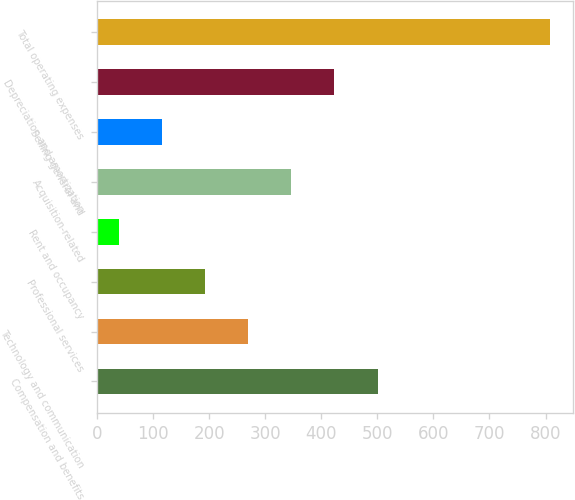Convert chart. <chart><loc_0><loc_0><loc_500><loc_500><bar_chart><fcel>Compensation and benefits<fcel>Technology and communication<fcel>Professional services<fcel>Rent and occupancy<fcel>Acquisition-related<fcel>Selling general and<fcel>Depreciation and amortization<fcel>Total operating expenses<nl><fcel>500.4<fcel>269.7<fcel>192.8<fcel>39<fcel>346.6<fcel>115.9<fcel>423.5<fcel>808<nl></chart> 